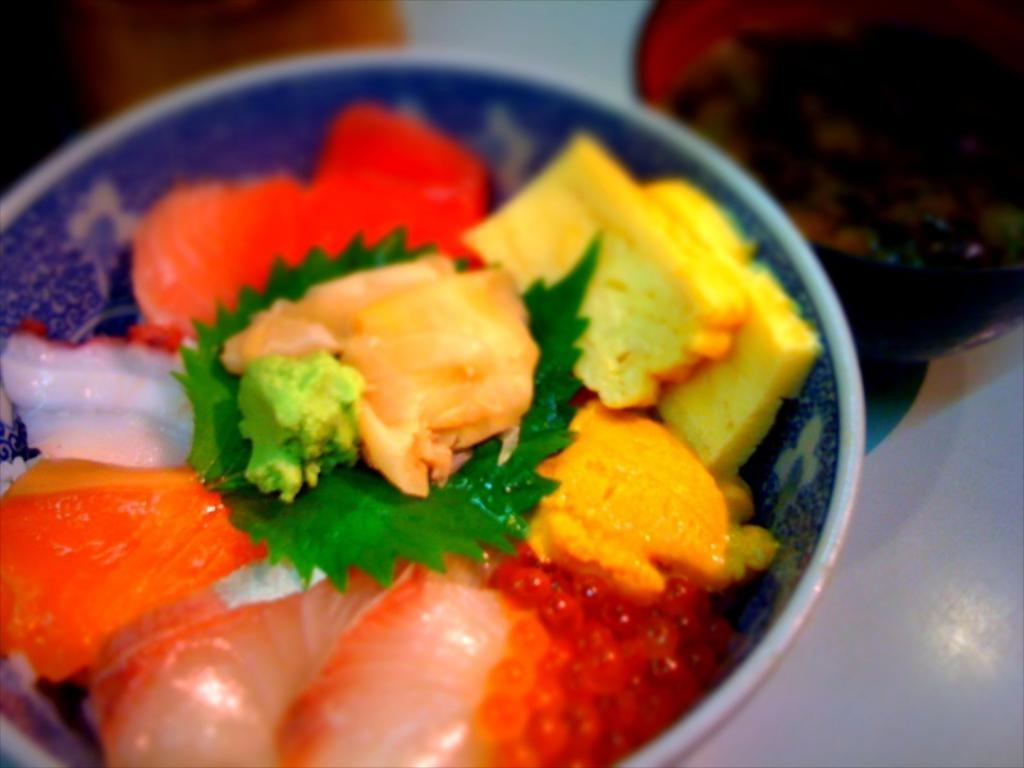What is in the bowl that is visible in the image? The bowl contains food stuff. What other items can be seen near the bowl in the image? There is a glass beside the bowl. What might be used for drinking or holding liquids in the image? The glass beside the bowl might be used for drinking or holding liquids. Can you see any monkeys in the image? No, there are no monkeys present in the image. What type of worm might be found in the food stuff in the bowl? There is no indication of any worms in the food stuff in the bowl, and we cannot make assumptions about the contents of the food. 